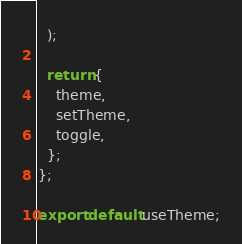<code> <loc_0><loc_0><loc_500><loc_500><_TypeScript_>  );

  return {
    theme,
    setTheme,
    toggle,
  };
};

export default useTheme;
</code> 